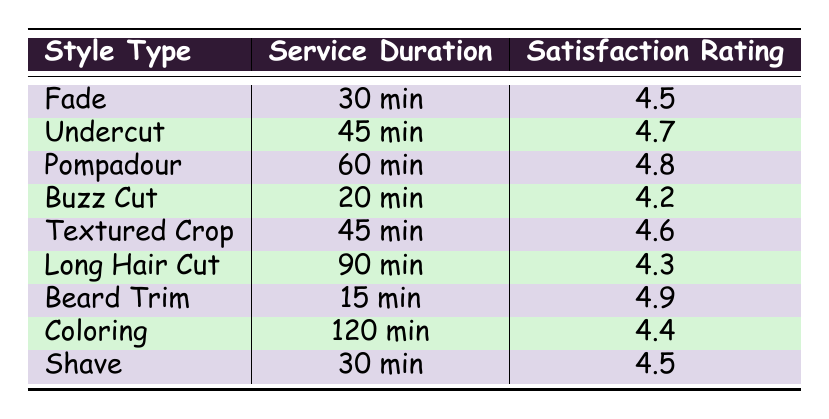What is the satisfaction rating for the Pompadour style? The table shows that the Pompadour style has a satisfaction rating of 4.8.
Answer: 4.8 How long does a Beard Trim service take? According to the table, the Beard Trim service takes 15 minutes.
Answer: 15 min What is the satisfaction rating for services that take 45 minutes? There are two services that take 45 minutes: Undercut with a rating of 4.7 and Textured Crop with a rating of 4.6. The average satisfaction rating for these services is (4.7 + 4.6) / 2 = 4.65.
Answer: 4.65 Is the satisfaction rating for Buzz Cut higher than for Fade? The satisfaction rating for Buzz Cut is 4.2 and for Fade it is 4.5. Since 4.2 is not higher than 4.5, the answer is no.
Answer: No What is the difference in satisfaction ratings between the longest and shortest service durations? The longest service duration is Coloring at 120 minutes with a rating of 4.4, and the shortest is Beard Trim at 15 minutes with a rating of 4.9. The difference in their ratings is 4.9 - 4.4 = 0.5.
Answer: 0.5 